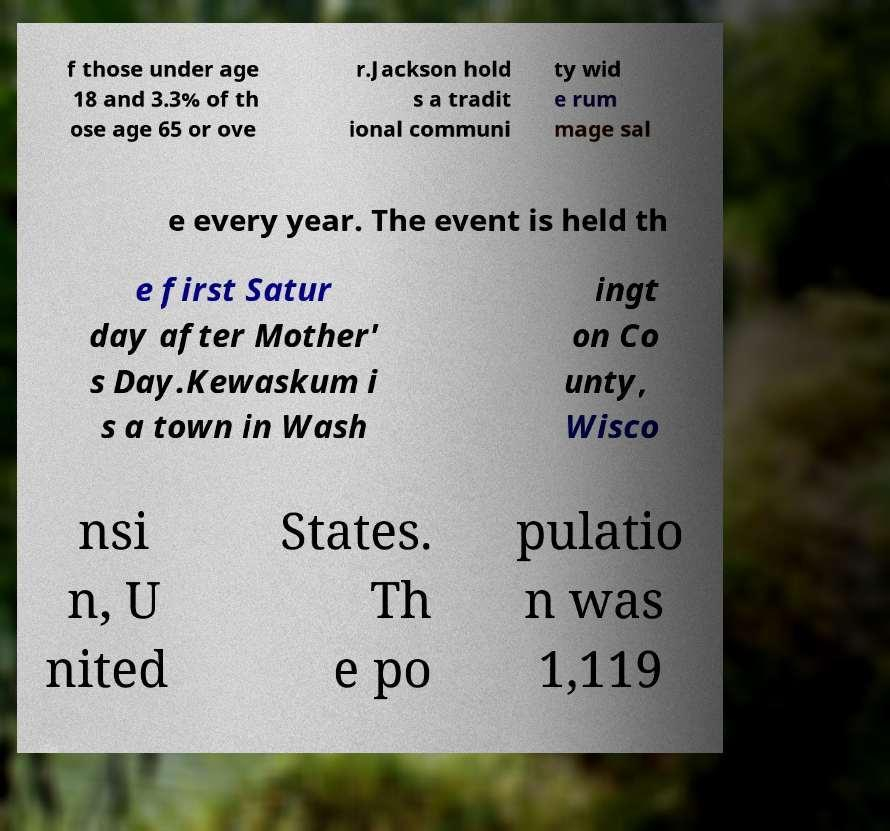Please read and relay the text visible in this image. What does it say? f those under age 18 and 3.3% of th ose age 65 or ove r.Jackson hold s a tradit ional communi ty wid e rum mage sal e every year. The event is held th e first Satur day after Mother' s Day.Kewaskum i s a town in Wash ingt on Co unty, Wisco nsi n, U nited States. Th e po pulatio n was 1,119 